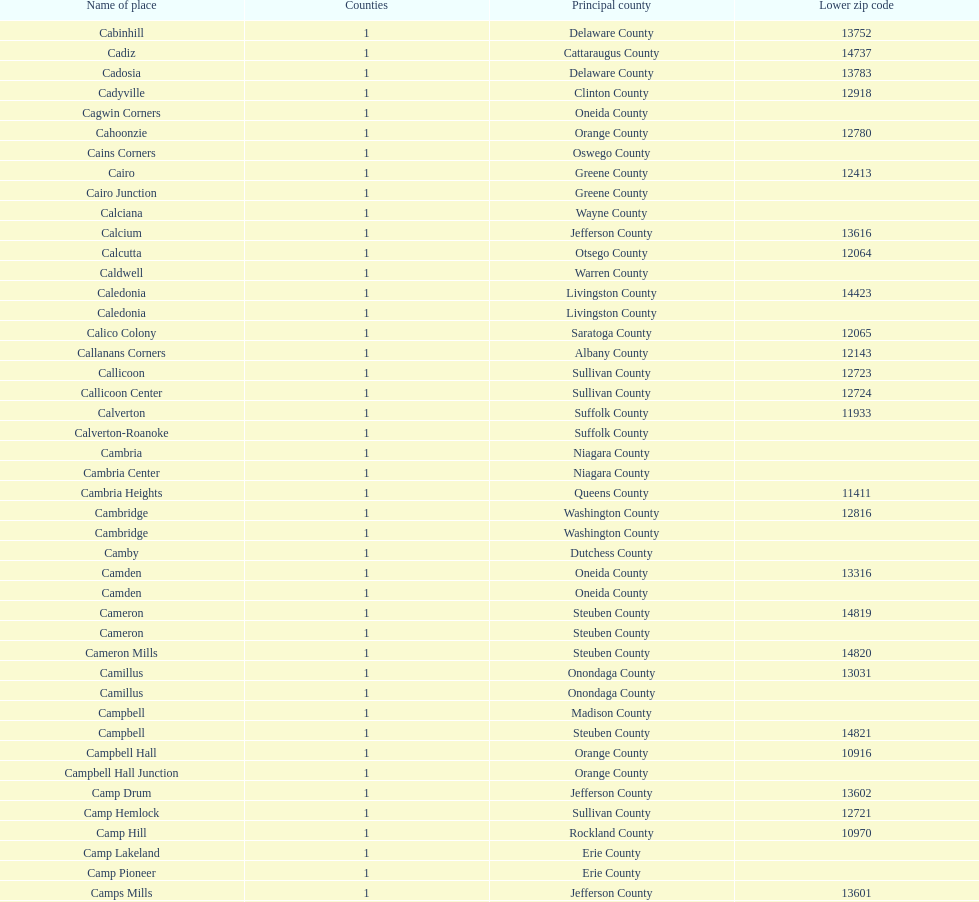Which spot has the minimum, inferior zip code? Cooper. 